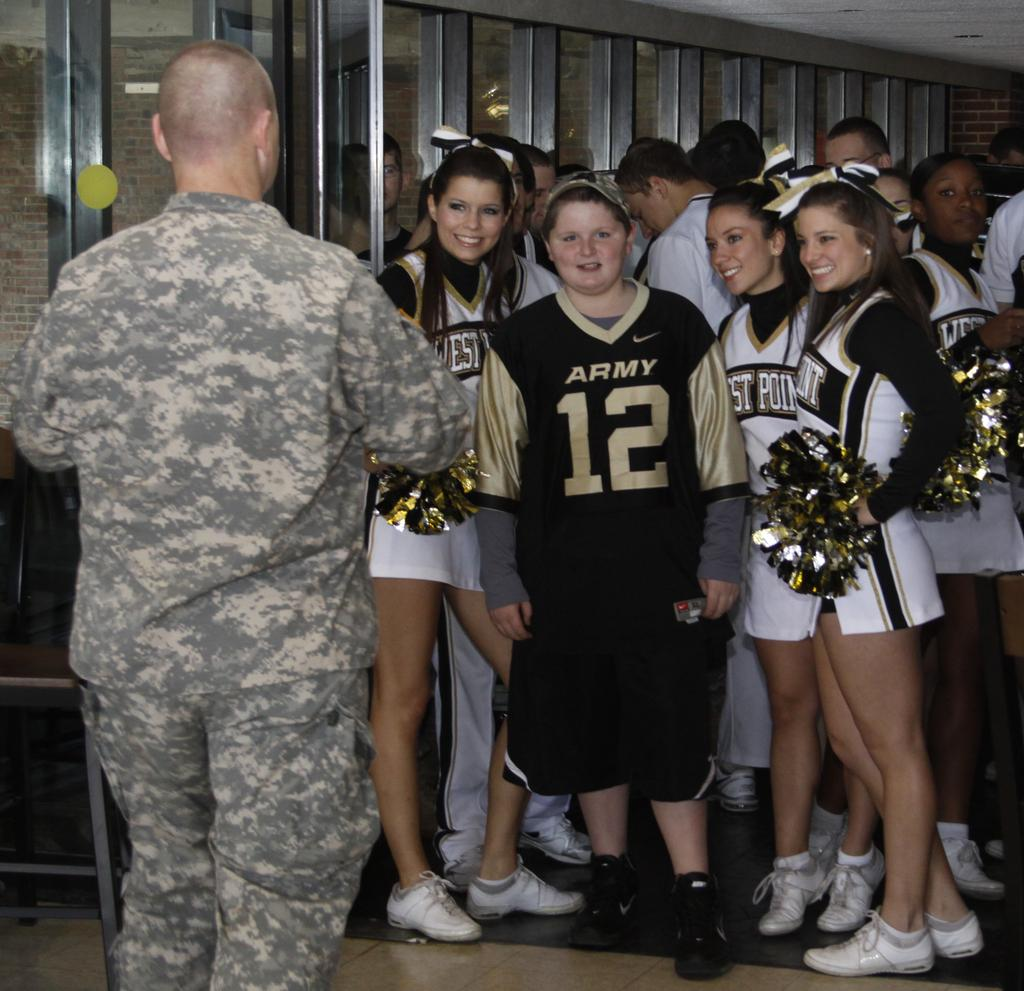<image>
Give a short and clear explanation of the subsequent image. Cheerleaders from West Point stand around a person in an Army shirt. 